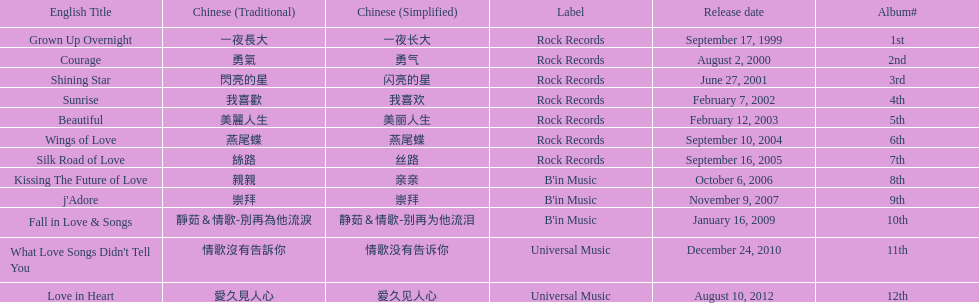Was the album beautiful released before the album love in heart? Yes. 